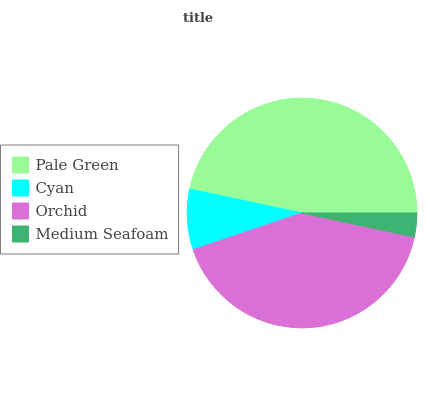Is Medium Seafoam the minimum?
Answer yes or no. Yes. Is Pale Green the maximum?
Answer yes or no. Yes. Is Cyan the minimum?
Answer yes or no. No. Is Cyan the maximum?
Answer yes or no. No. Is Pale Green greater than Cyan?
Answer yes or no. Yes. Is Cyan less than Pale Green?
Answer yes or no. Yes. Is Cyan greater than Pale Green?
Answer yes or no. No. Is Pale Green less than Cyan?
Answer yes or no. No. Is Orchid the high median?
Answer yes or no. Yes. Is Cyan the low median?
Answer yes or no. Yes. Is Pale Green the high median?
Answer yes or no. No. Is Orchid the low median?
Answer yes or no. No. 